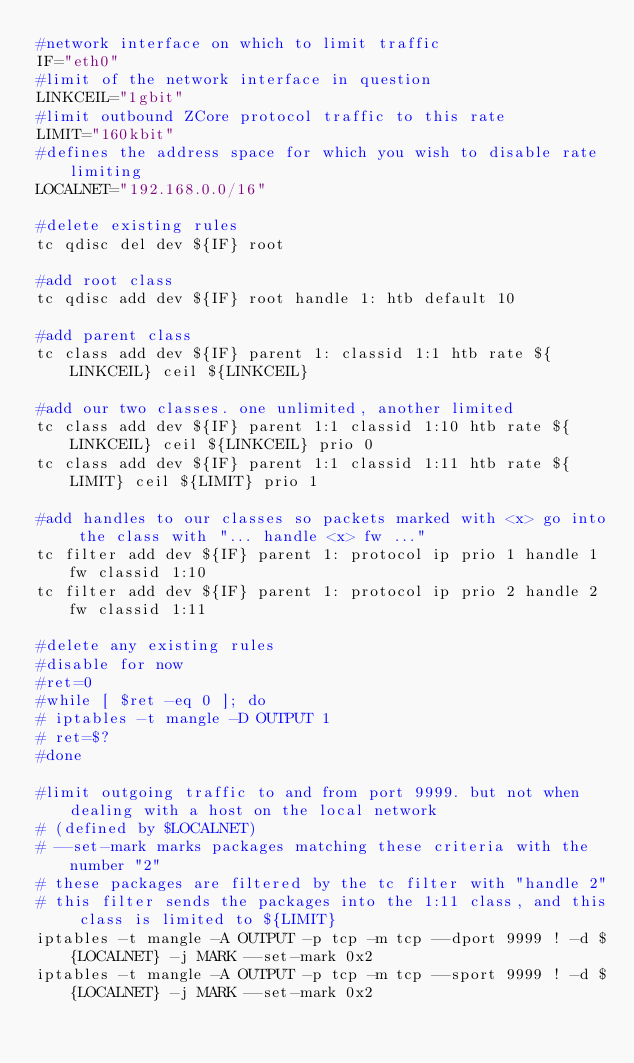Convert code to text. <code><loc_0><loc_0><loc_500><loc_500><_Bash_>#network interface on which to limit traffic
IF="eth0"
#limit of the network interface in question
LINKCEIL="1gbit"
#limit outbound ZCore protocol traffic to this rate
LIMIT="160kbit"
#defines the address space for which you wish to disable rate limiting
LOCALNET="192.168.0.0/16"

#delete existing rules
tc qdisc del dev ${IF} root

#add root class
tc qdisc add dev ${IF} root handle 1: htb default 10

#add parent class
tc class add dev ${IF} parent 1: classid 1:1 htb rate ${LINKCEIL} ceil ${LINKCEIL}

#add our two classes. one unlimited, another limited
tc class add dev ${IF} parent 1:1 classid 1:10 htb rate ${LINKCEIL} ceil ${LINKCEIL} prio 0
tc class add dev ${IF} parent 1:1 classid 1:11 htb rate ${LIMIT} ceil ${LIMIT} prio 1

#add handles to our classes so packets marked with <x> go into the class with "... handle <x> fw ..."
tc filter add dev ${IF} parent 1: protocol ip prio 1 handle 1 fw classid 1:10
tc filter add dev ${IF} parent 1: protocol ip prio 2 handle 2 fw classid 1:11

#delete any existing rules
#disable for now
#ret=0
#while [ $ret -eq 0 ]; do
#	iptables -t mangle -D OUTPUT 1
#	ret=$?
#done

#limit outgoing traffic to and from port 9999. but not when dealing with a host on the local network
#	(defined by $LOCALNET)
#	--set-mark marks packages matching these criteria with the number "2"
#	these packages are filtered by the tc filter with "handle 2"
#	this filter sends the packages into the 1:11 class, and this class is limited to ${LIMIT}
iptables -t mangle -A OUTPUT -p tcp -m tcp --dport 9999 ! -d ${LOCALNET} -j MARK --set-mark 0x2
iptables -t mangle -A OUTPUT -p tcp -m tcp --sport 9999 ! -d ${LOCALNET} -j MARK --set-mark 0x2
</code> 